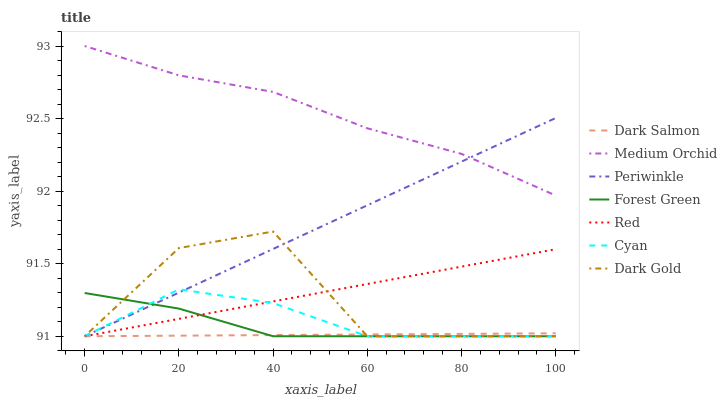Does Medium Orchid have the minimum area under the curve?
Answer yes or no. No. Does Dark Salmon have the maximum area under the curve?
Answer yes or no. No. Is Medium Orchid the smoothest?
Answer yes or no. No. Is Medium Orchid the roughest?
Answer yes or no. No. Does Medium Orchid have the lowest value?
Answer yes or no. No. Does Dark Salmon have the highest value?
Answer yes or no. No. Is Red less than Medium Orchid?
Answer yes or no. Yes. Is Medium Orchid greater than Dark Salmon?
Answer yes or no. Yes. Does Red intersect Medium Orchid?
Answer yes or no. No. 